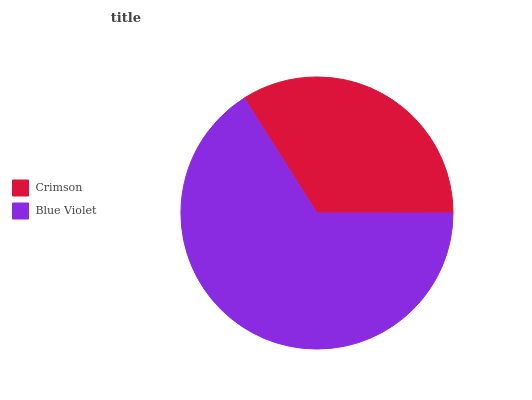Is Crimson the minimum?
Answer yes or no. Yes. Is Blue Violet the maximum?
Answer yes or no. Yes. Is Blue Violet the minimum?
Answer yes or no. No. Is Blue Violet greater than Crimson?
Answer yes or no. Yes. Is Crimson less than Blue Violet?
Answer yes or no. Yes. Is Crimson greater than Blue Violet?
Answer yes or no. No. Is Blue Violet less than Crimson?
Answer yes or no. No. Is Blue Violet the high median?
Answer yes or no. Yes. Is Crimson the low median?
Answer yes or no. Yes. Is Crimson the high median?
Answer yes or no. No. Is Blue Violet the low median?
Answer yes or no. No. 